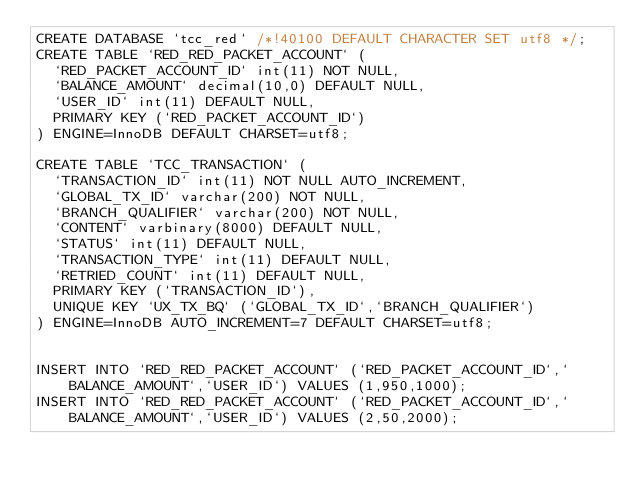Convert code to text. <code><loc_0><loc_0><loc_500><loc_500><_SQL_>CREATE DATABASE `tcc_red` /*!40100 DEFAULT CHARACTER SET utf8 */;
CREATE TABLE `RED_RED_PACKET_ACCOUNT` (
  `RED_PACKET_ACCOUNT_ID` int(11) NOT NULL,
  `BALANCE_AMOUNT` decimal(10,0) DEFAULT NULL,
  `USER_ID` int(11) DEFAULT NULL,
  PRIMARY KEY (`RED_PACKET_ACCOUNT_ID`)
) ENGINE=InnoDB DEFAULT CHARSET=utf8;

CREATE TABLE `TCC_TRANSACTION` (
  `TRANSACTION_ID` int(11) NOT NULL AUTO_INCREMENT,
  `GLOBAL_TX_ID` varchar(200) NOT NULL,
  `BRANCH_QUALIFIER` varchar(200) NOT NULL,
  `CONTENT` varbinary(8000) DEFAULT NULL,
  `STATUS` int(11) DEFAULT NULL,
  `TRANSACTION_TYPE` int(11) DEFAULT NULL,
  `RETRIED_COUNT` int(11) DEFAULT NULL,
  PRIMARY KEY (`TRANSACTION_ID`),
  UNIQUE KEY `UX_TX_BQ` (`GLOBAL_TX_ID`,`BRANCH_QUALIFIER`)
) ENGINE=InnoDB AUTO_INCREMENT=7 DEFAULT CHARSET=utf8;


INSERT INTO `RED_RED_PACKET_ACCOUNT` (`RED_PACKET_ACCOUNT_ID`,`BALANCE_AMOUNT`,`USER_ID`) VALUES (1,950,1000);
INSERT INTO `RED_RED_PACKET_ACCOUNT` (`RED_PACKET_ACCOUNT_ID`,`BALANCE_AMOUNT`,`USER_ID`) VALUES (2,50,2000);
</code> 